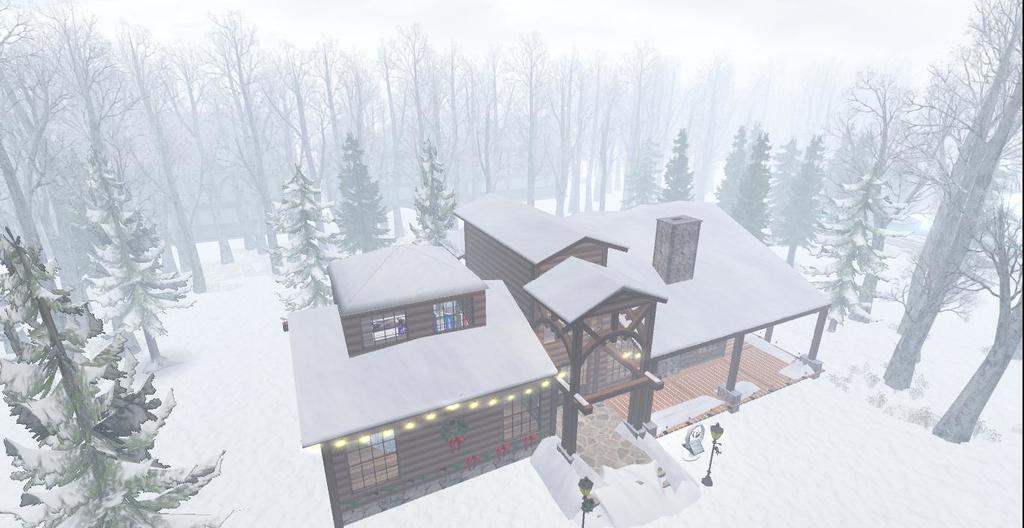What type of structure is present in the image? There is a house in the picture. What type of vegetation can be seen in the image? There are trees in the picture. What is the weather condition in the image? There is snow visible in the picture, indicating a cold or wintery condition. What type of lighting is present in the image? There are pole lights in the picture. How many toes are visible in the image? There are no toes visible in the image. What type of party is taking place in the image? There is no party present in the image. 